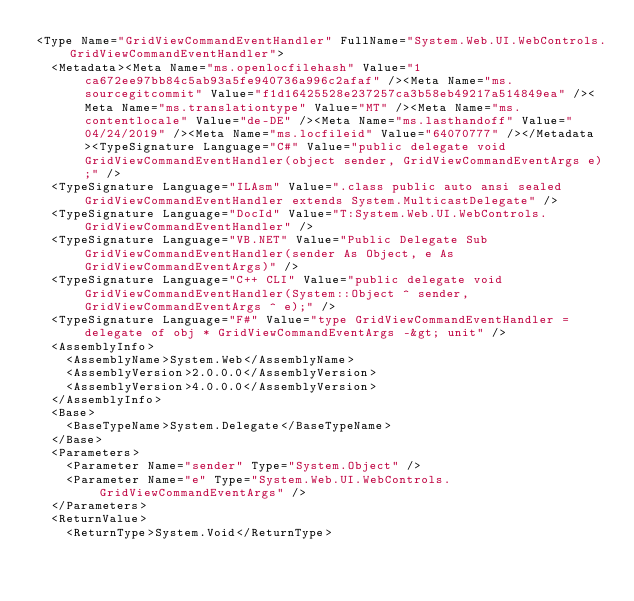<code> <loc_0><loc_0><loc_500><loc_500><_XML_><Type Name="GridViewCommandEventHandler" FullName="System.Web.UI.WebControls.GridViewCommandEventHandler">
  <Metadata><Meta Name="ms.openlocfilehash" Value="1ca672ee97bb84c5ab93a5fe940736a996c2afaf" /><Meta Name="ms.sourcegitcommit" Value="f1d16425528e237257ca3b58eb49217a514849ea" /><Meta Name="ms.translationtype" Value="MT" /><Meta Name="ms.contentlocale" Value="de-DE" /><Meta Name="ms.lasthandoff" Value="04/24/2019" /><Meta Name="ms.locfileid" Value="64070777" /></Metadata><TypeSignature Language="C#" Value="public delegate void GridViewCommandEventHandler(object sender, GridViewCommandEventArgs e);" />
  <TypeSignature Language="ILAsm" Value=".class public auto ansi sealed GridViewCommandEventHandler extends System.MulticastDelegate" />
  <TypeSignature Language="DocId" Value="T:System.Web.UI.WebControls.GridViewCommandEventHandler" />
  <TypeSignature Language="VB.NET" Value="Public Delegate Sub GridViewCommandEventHandler(sender As Object, e As GridViewCommandEventArgs)" />
  <TypeSignature Language="C++ CLI" Value="public delegate void GridViewCommandEventHandler(System::Object ^ sender, GridViewCommandEventArgs ^ e);" />
  <TypeSignature Language="F#" Value="type GridViewCommandEventHandler = delegate of obj * GridViewCommandEventArgs -&gt; unit" />
  <AssemblyInfo>
    <AssemblyName>System.Web</AssemblyName>
    <AssemblyVersion>2.0.0.0</AssemblyVersion>
    <AssemblyVersion>4.0.0.0</AssemblyVersion>
  </AssemblyInfo>
  <Base>
    <BaseTypeName>System.Delegate</BaseTypeName>
  </Base>
  <Parameters>
    <Parameter Name="sender" Type="System.Object" />
    <Parameter Name="e" Type="System.Web.UI.WebControls.GridViewCommandEventArgs" />
  </Parameters>
  <ReturnValue>
    <ReturnType>System.Void</ReturnType></code> 